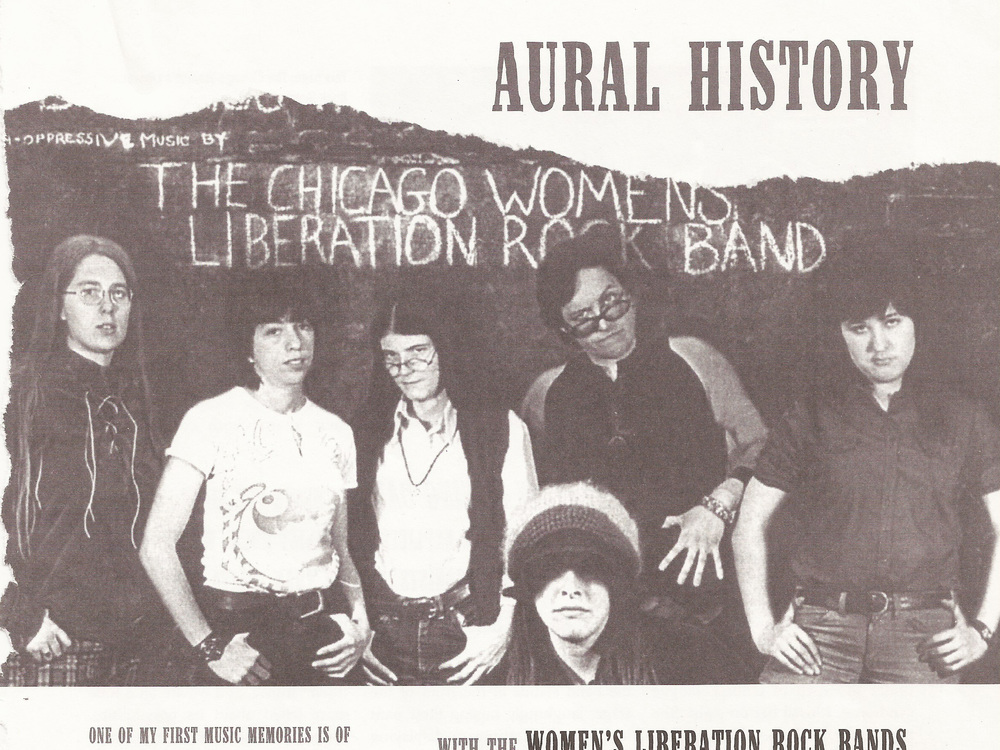What could the graphic print on the t-shirt of the second individual from the left symbolize or indicate about the era or the band's interests? The graphic print on the t-shirt of the second person from the left, which features a sun-like design with petals possibly hinting at a flower, can be emblematic of the 1960s and 1970s. This period was defined by a fervent counterculture movement that emphasized peace, love, and an attunement to nature, qualities that the image exhales. Given the alignment of this design with psychedelic and folk music trends, it's quite plausible that the individual chose this imagery to reflect a personal or the band's aesthetic and philosophical commitment to these ideals. These musical genres were tightly intertwined with advancements in social justice, including the women's liberation movement, suggesting that the band might use their platform to broadcast similar progressive messages embedded within their music and appearance. 